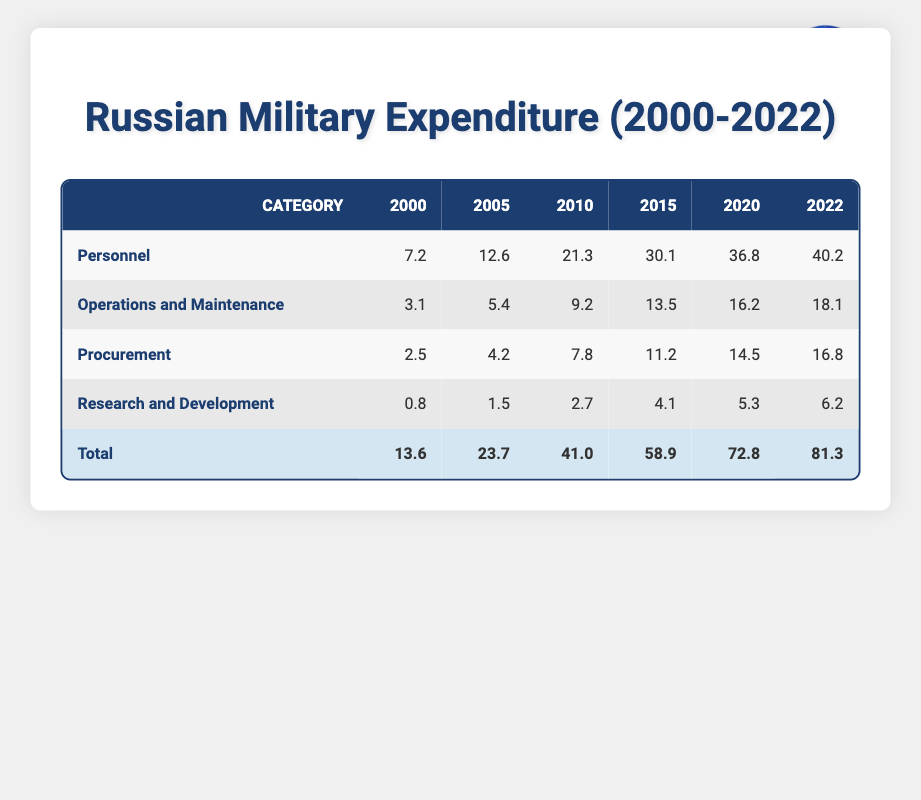What was the total military expenditure in 2010? To find the total military expenditure in 2010, we need to sum the expenditures of all categories for that year. The values are: Personnel (21.3), Operations and Maintenance (9.2), Procurement (7.8), and Research and Development (2.7). Adding these gives us 21.3 + 9.2 + 7.8 + 2.7 = 41.0
Answer: 41.0 Which category saw the highest expenditure in 2022? Looking at the expenditures for 2022: Personnel (40.2), Operations and Maintenance (18.1), Procurement (16.8), and Research and Development (6.2). Personnel has the highest value at 40.2
Answer: Personnel Did the expenditure on Research and Development increase from 2000 to 2022? The expenditure on Research and Development in 2000 was 0.8, while in 2022 it was 6.2. To check for an increase, we can observe that 6.2 is greater than 0.8, indicating that the expenditure did increase
Answer: Yes What was the average expenditure on Procurement over the years 2000 to 2022? The Procurement expenditures are: 2.5 (2000), 4.2 (2005), 7.8 (2010), 11.2 (2015), 14.5 (2020), and 16.8 (2022). There are 6 data points. First, we sum these values: 2.5 + 4.2 + 7.8 + 11.2 + 14.5 + 16.8 = 56.0. Then we divide by 6 to get the average: 56.0 / 6 = 9.33
Answer: 9.33 In which year did the Operations and Maintenance expenditure first exceed 10? Checking the Operations and Maintenance expenditures: 3.1 (2000), 5.4 (2005), 9.2 (2010), and 13.5 (2015). The first value to exceed 10 is from the year 2015 when it was 13.5
Answer: 2015 Which category shows the greatest percentage increase from 2000 to 2022? To find the percentage increase for each category, we can use the formula: ((Final Value - Initial Value) / Initial Value) * 100. For Personnel: ((40.2 - 7.2) / 7.2) * 100 = 458.33%. Operations and Maintenance: ((18.1 - 3.1) / 3.1) * 100 = 484.84%. Procurement: ((16.8 - 2.5) / 2.5) * 100 = 572%. Research and Development: ((6.2 - 0.8) / 0.8) * 100 = 675%. Research and Development shows the greatest percentage increase
Answer: Research and Development Did total military expenditure decrease from 2015 to 2020? The total military expenditure in 2015 was 58.9, and in 2020 it was 72.8. Since 72.8 is greater than 58.9, total military expenditure did not decrease
Answer: No What is the difference in expenditure between Personnel and Operations and Maintenance in 2022? In 2022, the expenditures are: Personnel (40.2) and Operations and Maintenance (18.1). To find the difference, we subtract: 40.2 - 18.1 = 22.1
Answer: 22.1 